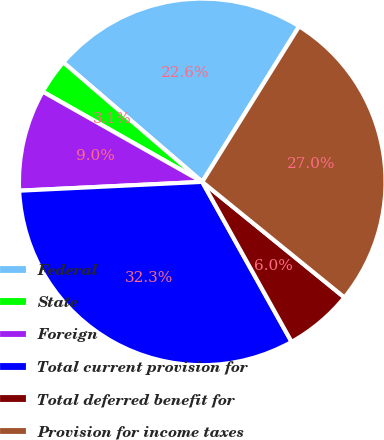<chart> <loc_0><loc_0><loc_500><loc_500><pie_chart><fcel>Federal<fcel>State<fcel>Foreign<fcel>Total current provision for<fcel>Total deferred benefit for<fcel>Provision for income taxes<nl><fcel>22.56%<fcel>3.11%<fcel>8.96%<fcel>32.34%<fcel>6.03%<fcel>27.0%<nl></chart> 